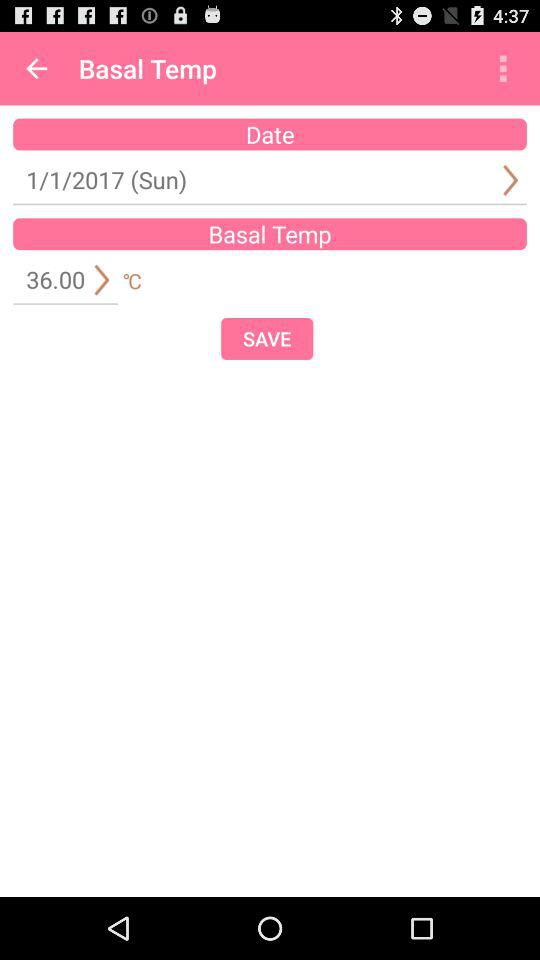What's the date? The date is Sunday, January 1, 2017. 